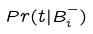<formula> <loc_0><loc_0><loc_500><loc_500>P r ( t | B _ { i } ^ { - } )</formula> 